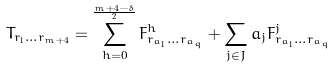Convert formula to latex. <formula><loc_0><loc_0><loc_500><loc_500>T _ { r _ { 1 } \dots r _ { m + 4 } } = \sum _ { h = 0 } ^ { \frac { m + 4 - \delta } { 2 } } F ^ { h } _ { r _ { a _ { 1 } } \dots r _ { a _ { q } } } + \sum _ { j \in J } a _ { j } F ^ { j } _ { r _ { a _ { 1 } } \dots r _ { a _ { q } } }</formula> 